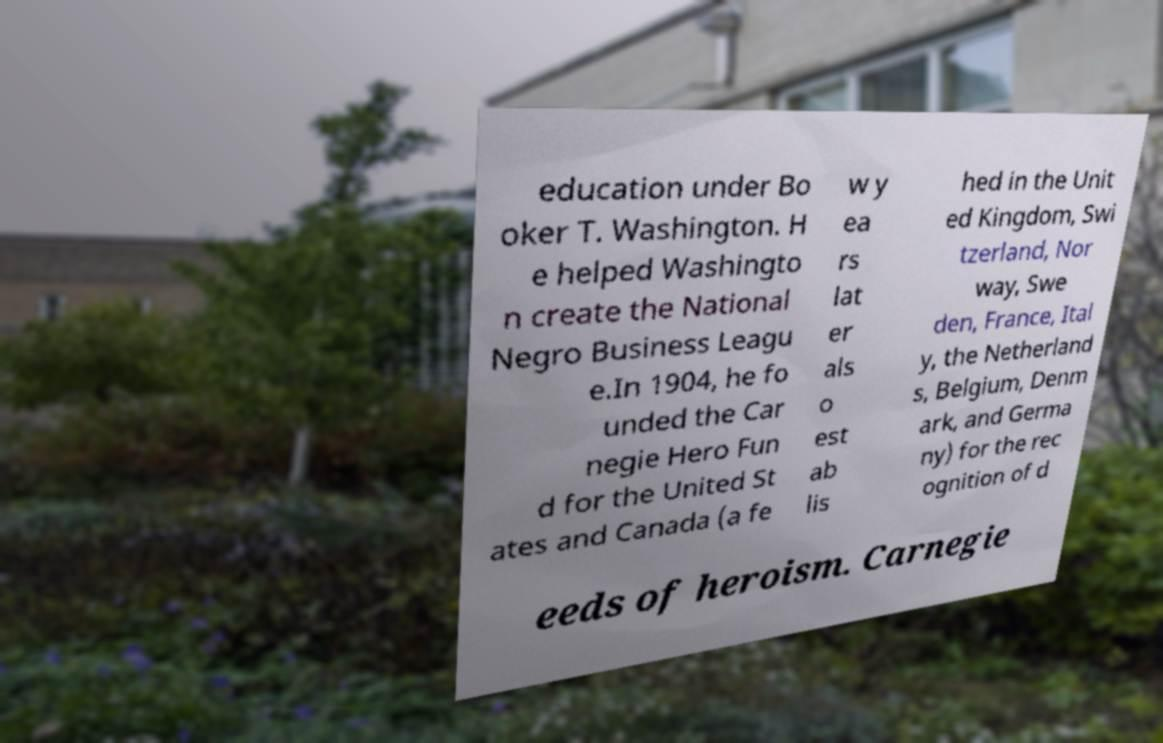I need the written content from this picture converted into text. Can you do that? education under Bo oker T. Washington. H e helped Washingto n create the National Negro Business Leagu e.In 1904, he fo unded the Car negie Hero Fun d for the United St ates and Canada (a fe w y ea rs lat er als o est ab lis hed in the Unit ed Kingdom, Swi tzerland, Nor way, Swe den, France, Ital y, the Netherland s, Belgium, Denm ark, and Germa ny) for the rec ognition of d eeds of heroism. Carnegie 